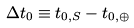Convert formula to latex. <formula><loc_0><loc_0><loc_500><loc_500>\Delta t _ { 0 } \equiv t _ { 0 , S } - t _ { 0 , \oplus }</formula> 